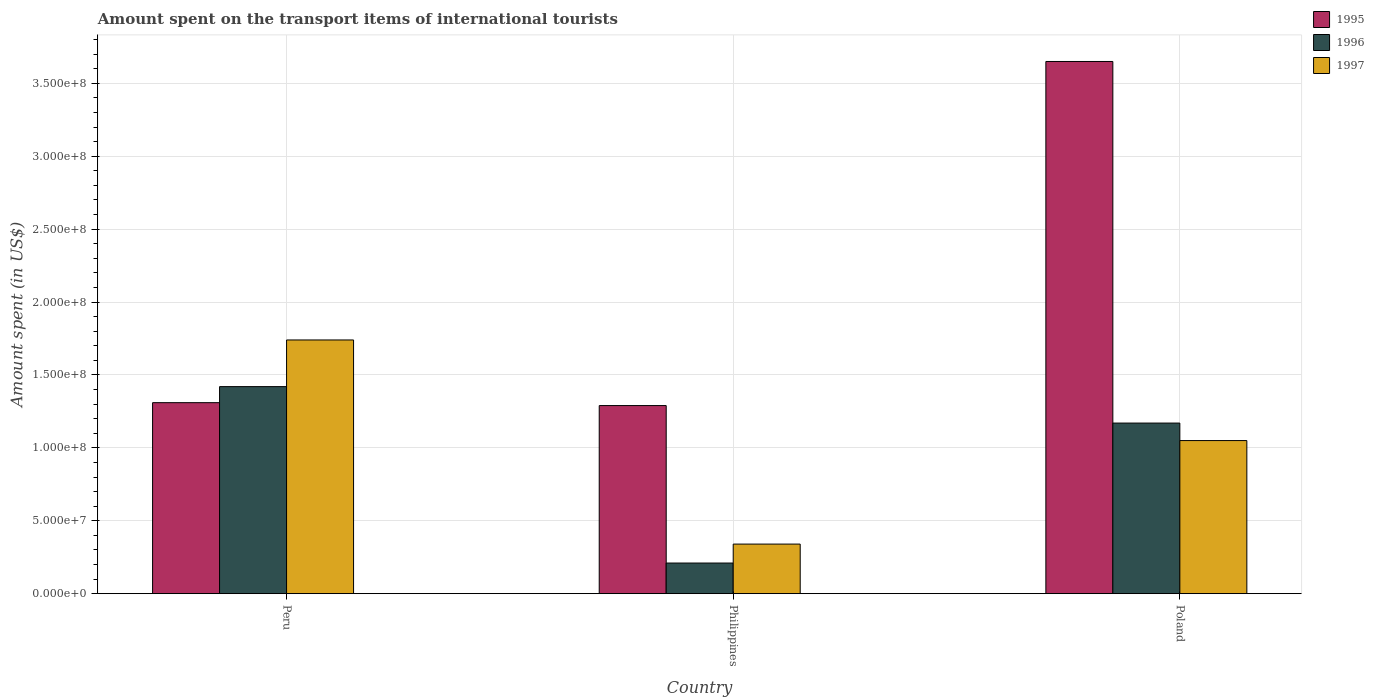How many groups of bars are there?
Offer a terse response. 3. Are the number of bars on each tick of the X-axis equal?
Your answer should be compact. Yes. What is the label of the 1st group of bars from the left?
Provide a short and direct response. Peru. What is the amount spent on the transport items of international tourists in 1997 in Poland?
Provide a short and direct response. 1.05e+08. Across all countries, what is the maximum amount spent on the transport items of international tourists in 1996?
Provide a succinct answer. 1.42e+08. Across all countries, what is the minimum amount spent on the transport items of international tourists in 1996?
Your answer should be compact. 2.10e+07. In which country was the amount spent on the transport items of international tourists in 1997 maximum?
Offer a very short reply. Peru. In which country was the amount spent on the transport items of international tourists in 1995 minimum?
Your answer should be compact. Philippines. What is the total amount spent on the transport items of international tourists in 1997 in the graph?
Your answer should be compact. 3.13e+08. What is the difference between the amount spent on the transport items of international tourists in 1996 in Philippines and that in Poland?
Offer a very short reply. -9.60e+07. What is the difference between the amount spent on the transport items of international tourists in 1997 in Philippines and the amount spent on the transport items of international tourists in 1996 in Poland?
Your answer should be very brief. -8.30e+07. What is the average amount spent on the transport items of international tourists in 1997 per country?
Your answer should be compact. 1.04e+08. What is the difference between the amount spent on the transport items of international tourists of/in 1996 and amount spent on the transport items of international tourists of/in 1995 in Peru?
Your response must be concise. 1.10e+07. What is the ratio of the amount spent on the transport items of international tourists in 1995 in Peru to that in Poland?
Keep it short and to the point. 0.36. Is the difference between the amount spent on the transport items of international tourists in 1996 in Peru and Philippines greater than the difference between the amount spent on the transport items of international tourists in 1995 in Peru and Philippines?
Ensure brevity in your answer.  Yes. What is the difference between the highest and the second highest amount spent on the transport items of international tourists in 1995?
Make the answer very short. 2.36e+08. What is the difference between the highest and the lowest amount spent on the transport items of international tourists in 1996?
Your answer should be very brief. 1.21e+08. In how many countries, is the amount spent on the transport items of international tourists in 1995 greater than the average amount spent on the transport items of international tourists in 1995 taken over all countries?
Your response must be concise. 1. What does the 1st bar from the right in Peru represents?
Keep it short and to the point. 1997. Is it the case that in every country, the sum of the amount spent on the transport items of international tourists in 1997 and amount spent on the transport items of international tourists in 1996 is greater than the amount spent on the transport items of international tourists in 1995?
Your answer should be compact. No. What is the difference between two consecutive major ticks on the Y-axis?
Offer a terse response. 5.00e+07. Does the graph contain any zero values?
Ensure brevity in your answer.  No. How many legend labels are there?
Your response must be concise. 3. What is the title of the graph?
Your answer should be compact. Amount spent on the transport items of international tourists. Does "1994" appear as one of the legend labels in the graph?
Make the answer very short. No. What is the label or title of the X-axis?
Your answer should be very brief. Country. What is the label or title of the Y-axis?
Make the answer very short. Amount spent (in US$). What is the Amount spent (in US$) of 1995 in Peru?
Offer a very short reply. 1.31e+08. What is the Amount spent (in US$) in 1996 in Peru?
Offer a terse response. 1.42e+08. What is the Amount spent (in US$) of 1997 in Peru?
Give a very brief answer. 1.74e+08. What is the Amount spent (in US$) of 1995 in Philippines?
Offer a very short reply. 1.29e+08. What is the Amount spent (in US$) in 1996 in Philippines?
Keep it short and to the point. 2.10e+07. What is the Amount spent (in US$) in 1997 in Philippines?
Make the answer very short. 3.40e+07. What is the Amount spent (in US$) of 1995 in Poland?
Provide a short and direct response. 3.65e+08. What is the Amount spent (in US$) in 1996 in Poland?
Offer a terse response. 1.17e+08. What is the Amount spent (in US$) of 1997 in Poland?
Your response must be concise. 1.05e+08. Across all countries, what is the maximum Amount spent (in US$) of 1995?
Your response must be concise. 3.65e+08. Across all countries, what is the maximum Amount spent (in US$) in 1996?
Offer a very short reply. 1.42e+08. Across all countries, what is the maximum Amount spent (in US$) in 1997?
Provide a succinct answer. 1.74e+08. Across all countries, what is the minimum Amount spent (in US$) of 1995?
Your answer should be compact. 1.29e+08. Across all countries, what is the minimum Amount spent (in US$) in 1996?
Provide a succinct answer. 2.10e+07. Across all countries, what is the minimum Amount spent (in US$) in 1997?
Give a very brief answer. 3.40e+07. What is the total Amount spent (in US$) of 1995 in the graph?
Keep it short and to the point. 6.25e+08. What is the total Amount spent (in US$) in 1996 in the graph?
Offer a terse response. 2.80e+08. What is the total Amount spent (in US$) in 1997 in the graph?
Give a very brief answer. 3.13e+08. What is the difference between the Amount spent (in US$) in 1995 in Peru and that in Philippines?
Your answer should be compact. 2.00e+06. What is the difference between the Amount spent (in US$) in 1996 in Peru and that in Philippines?
Provide a short and direct response. 1.21e+08. What is the difference between the Amount spent (in US$) in 1997 in Peru and that in Philippines?
Provide a short and direct response. 1.40e+08. What is the difference between the Amount spent (in US$) of 1995 in Peru and that in Poland?
Provide a succinct answer. -2.34e+08. What is the difference between the Amount spent (in US$) of 1996 in Peru and that in Poland?
Provide a short and direct response. 2.50e+07. What is the difference between the Amount spent (in US$) of 1997 in Peru and that in Poland?
Ensure brevity in your answer.  6.90e+07. What is the difference between the Amount spent (in US$) of 1995 in Philippines and that in Poland?
Make the answer very short. -2.36e+08. What is the difference between the Amount spent (in US$) in 1996 in Philippines and that in Poland?
Make the answer very short. -9.60e+07. What is the difference between the Amount spent (in US$) of 1997 in Philippines and that in Poland?
Keep it short and to the point. -7.10e+07. What is the difference between the Amount spent (in US$) in 1995 in Peru and the Amount spent (in US$) in 1996 in Philippines?
Your answer should be very brief. 1.10e+08. What is the difference between the Amount spent (in US$) in 1995 in Peru and the Amount spent (in US$) in 1997 in Philippines?
Make the answer very short. 9.70e+07. What is the difference between the Amount spent (in US$) in 1996 in Peru and the Amount spent (in US$) in 1997 in Philippines?
Provide a short and direct response. 1.08e+08. What is the difference between the Amount spent (in US$) in 1995 in Peru and the Amount spent (in US$) in 1996 in Poland?
Ensure brevity in your answer.  1.40e+07. What is the difference between the Amount spent (in US$) of 1995 in Peru and the Amount spent (in US$) of 1997 in Poland?
Provide a short and direct response. 2.60e+07. What is the difference between the Amount spent (in US$) of 1996 in Peru and the Amount spent (in US$) of 1997 in Poland?
Your answer should be compact. 3.70e+07. What is the difference between the Amount spent (in US$) in 1995 in Philippines and the Amount spent (in US$) in 1997 in Poland?
Offer a terse response. 2.40e+07. What is the difference between the Amount spent (in US$) of 1996 in Philippines and the Amount spent (in US$) of 1997 in Poland?
Offer a very short reply. -8.40e+07. What is the average Amount spent (in US$) in 1995 per country?
Keep it short and to the point. 2.08e+08. What is the average Amount spent (in US$) in 1996 per country?
Keep it short and to the point. 9.33e+07. What is the average Amount spent (in US$) in 1997 per country?
Keep it short and to the point. 1.04e+08. What is the difference between the Amount spent (in US$) in 1995 and Amount spent (in US$) in 1996 in Peru?
Provide a short and direct response. -1.10e+07. What is the difference between the Amount spent (in US$) in 1995 and Amount spent (in US$) in 1997 in Peru?
Ensure brevity in your answer.  -4.30e+07. What is the difference between the Amount spent (in US$) of 1996 and Amount spent (in US$) of 1997 in Peru?
Provide a succinct answer. -3.20e+07. What is the difference between the Amount spent (in US$) in 1995 and Amount spent (in US$) in 1996 in Philippines?
Ensure brevity in your answer.  1.08e+08. What is the difference between the Amount spent (in US$) in 1995 and Amount spent (in US$) in 1997 in Philippines?
Provide a short and direct response. 9.50e+07. What is the difference between the Amount spent (in US$) in 1996 and Amount spent (in US$) in 1997 in Philippines?
Your answer should be compact. -1.30e+07. What is the difference between the Amount spent (in US$) in 1995 and Amount spent (in US$) in 1996 in Poland?
Your answer should be compact. 2.48e+08. What is the difference between the Amount spent (in US$) in 1995 and Amount spent (in US$) in 1997 in Poland?
Make the answer very short. 2.60e+08. What is the ratio of the Amount spent (in US$) of 1995 in Peru to that in Philippines?
Provide a succinct answer. 1.02. What is the ratio of the Amount spent (in US$) in 1996 in Peru to that in Philippines?
Provide a short and direct response. 6.76. What is the ratio of the Amount spent (in US$) in 1997 in Peru to that in Philippines?
Make the answer very short. 5.12. What is the ratio of the Amount spent (in US$) of 1995 in Peru to that in Poland?
Offer a very short reply. 0.36. What is the ratio of the Amount spent (in US$) in 1996 in Peru to that in Poland?
Your response must be concise. 1.21. What is the ratio of the Amount spent (in US$) of 1997 in Peru to that in Poland?
Provide a short and direct response. 1.66. What is the ratio of the Amount spent (in US$) in 1995 in Philippines to that in Poland?
Give a very brief answer. 0.35. What is the ratio of the Amount spent (in US$) in 1996 in Philippines to that in Poland?
Give a very brief answer. 0.18. What is the ratio of the Amount spent (in US$) of 1997 in Philippines to that in Poland?
Provide a short and direct response. 0.32. What is the difference between the highest and the second highest Amount spent (in US$) in 1995?
Provide a succinct answer. 2.34e+08. What is the difference between the highest and the second highest Amount spent (in US$) in 1996?
Your answer should be compact. 2.50e+07. What is the difference between the highest and the second highest Amount spent (in US$) in 1997?
Your answer should be compact. 6.90e+07. What is the difference between the highest and the lowest Amount spent (in US$) of 1995?
Give a very brief answer. 2.36e+08. What is the difference between the highest and the lowest Amount spent (in US$) of 1996?
Offer a terse response. 1.21e+08. What is the difference between the highest and the lowest Amount spent (in US$) of 1997?
Provide a succinct answer. 1.40e+08. 